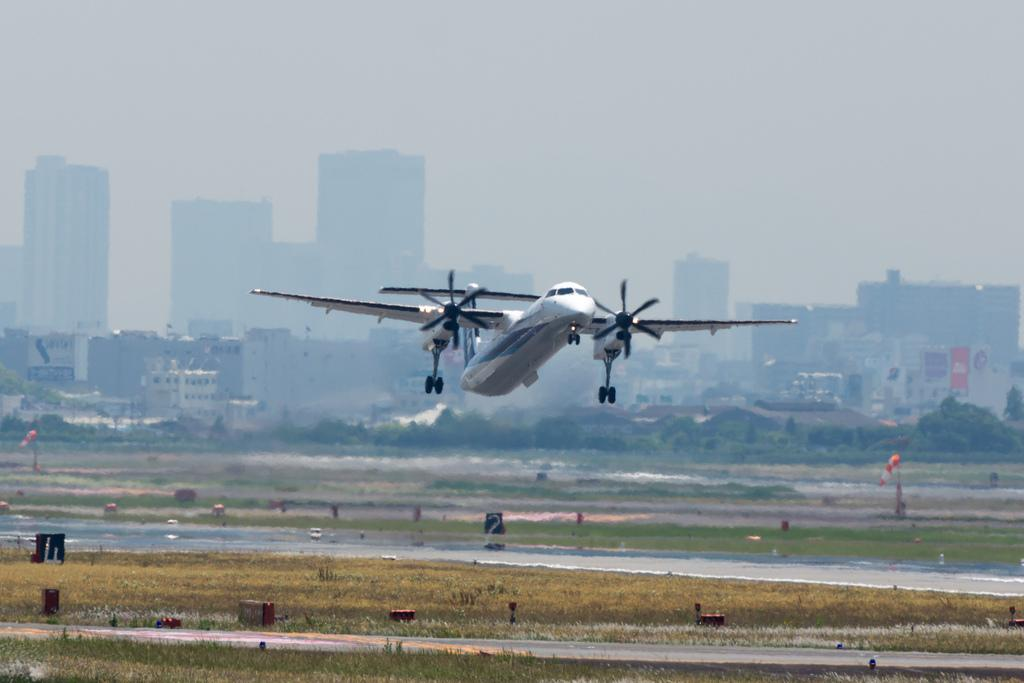What is the main subject of the image? The main subject of the image is an airplane flying in the air. What is located below the airplane? There is a runway below the airplane. What can be seen in the background of the image? There are buildings, trees, and the sky visible in the background of the image. What type of show is being performed in the cellar in the image? There is no cellar or show present in the image; it features an airplane flying above a runway with buildings, trees, and the sky in the background. 